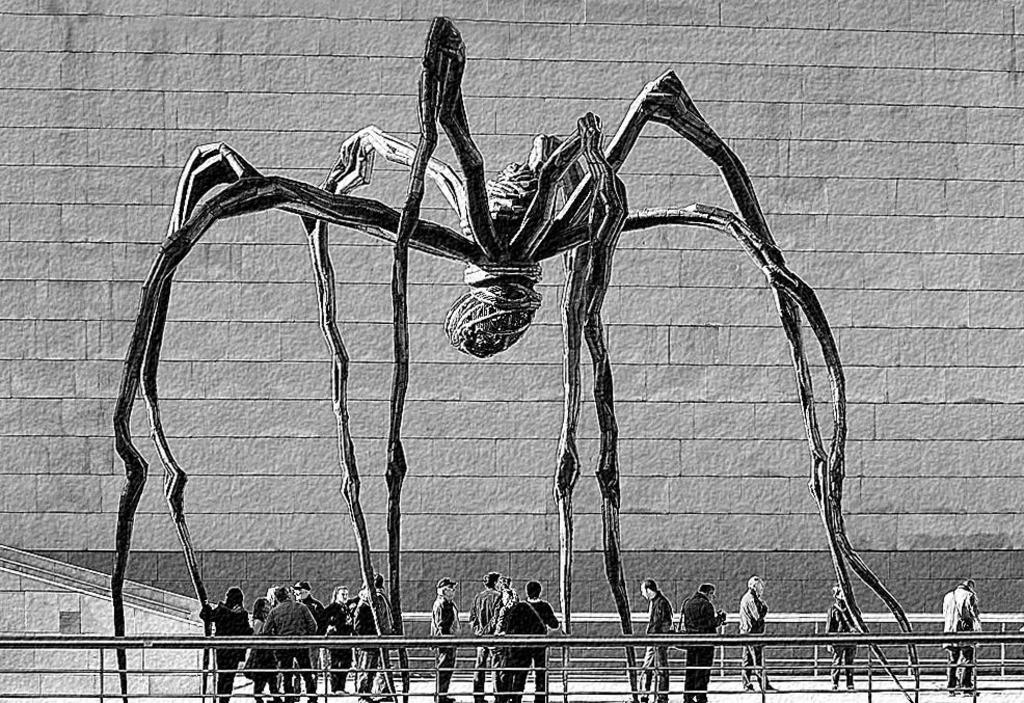What is the color scheme of the image? The image is black and white. What are the people in the image doing? The people are standing on a path in the image. What can be seen in the background of the image? There is a wall in the background of the image. What type of barrier is present in the image? There is a fence in the image. Can you tell me how many umbrellas are being used by the people in the image? There are no umbrellas present in the image; it is a black and white image of people standing on a path with a wall in the background and a fence. What type of treatment is being administered to the donkey in the image? There is no donkey present in the image, so no treatment can be observed. 